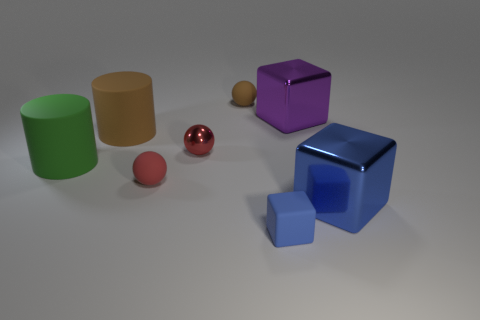Add 2 tiny blue objects. How many objects exist? 10 Subtract all blocks. How many objects are left? 5 Add 4 big metal objects. How many big metal objects are left? 6 Add 4 big cyan matte cylinders. How many big cyan matte cylinders exist? 4 Subtract 0 cyan cubes. How many objects are left? 8 Subtract all balls. Subtract all large purple metal spheres. How many objects are left? 5 